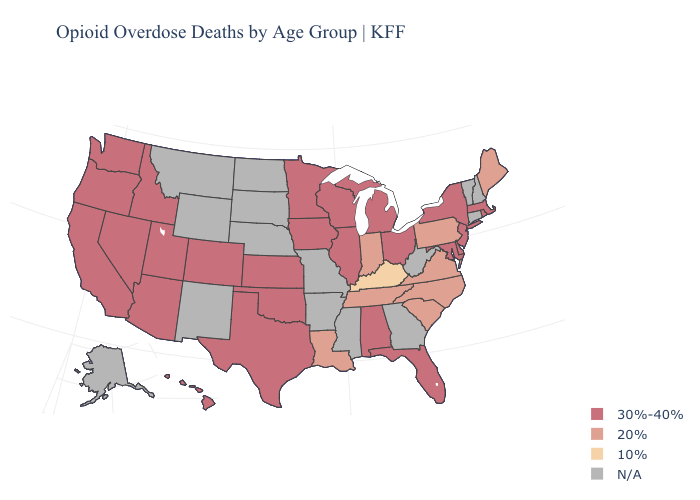Which states have the lowest value in the USA?
Be succinct. Kentucky. What is the value of California?
Short answer required. 30%-40%. Does the map have missing data?
Concise answer only. Yes. Does Utah have the lowest value in the USA?
Concise answer only. No. Name the states that have a value in the range 30%-40%?
Concise answer only. Alabama, Arizona, California, Colorado, Delaware, Florida, Hawaii, Idaho, Illinois, Iowa, Kansas, Maryland, Massachusetts, Michigan, Minnesota, Nevada, New Jersey, New York, Ohio, Oklahoma, Oregon, Rhode Island, Texas, Utah, Washington, Wisconsin. What is the lowest value in the Northeast?
Quick response, please. 20%. What is the value of Minnesota?
Quick response, please. 30%-40%. Name the states that have a value in the range 30%-40%?
Answer briefly. Alabama, Arizona, California, Colorado, Delaware, Florida, Hawaii, Idaho, Illinois, Iowa, Kansas, Maryland, Massachusetts, Michigan, Minnesota, Nevada, New Jersey, New York, Ohio, Oklahoma, Oregon, Rhode Island, Texas, Utah, Washington, Wisconsin. Does Maine have the highest value in the Northeast?
Give a very brief answer. No. Which states hav the highest value in the Northeast?
Be succinct. Massachusetts, New Jersey, New York, Rhode Island. Among the states that border California , which have the lowest value?
Short answer required. Arizona, Nevada, Oregon. Name the states that have a value in the range 10%?
Keep it brief. Kentucky. Does Nevada have the highest value in the USA?
Short answer required. Yes. What is the value of Washington?
Be succinct. 30%-40%. What is the lowest value in the MidWest?
Write a very short answer. 20%. 